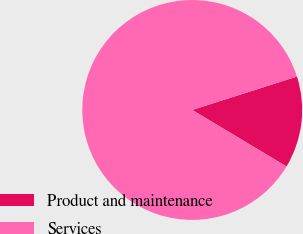Convert chart. <chart><loc_0><loc_0><loc_500><loc_500><pie_chart><fcel>Product and maintenance<fcel>Services<nl><fcel>13.51%<fcel>86.49%<nl></chart> 